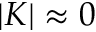Convert formula to latex. <formula><loc_0><loc_0><loc_500><loc_500>| K | \approx 0</formula> 